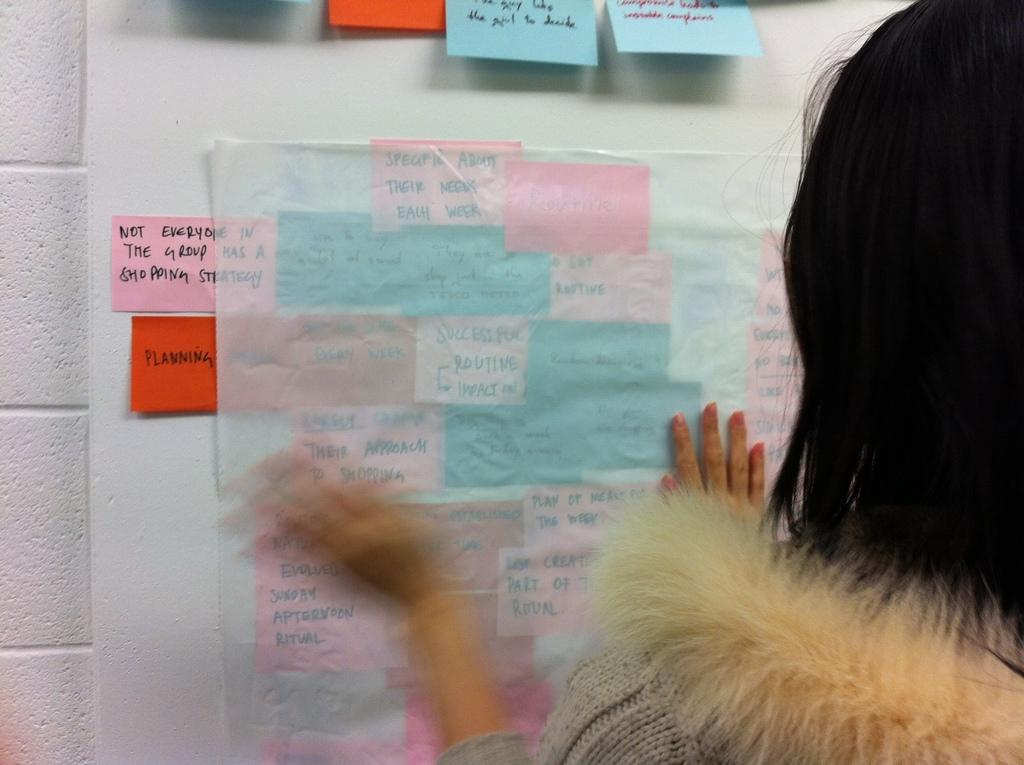Who is the main subject in the image? There is a lady in the image. What is the lady doing in the image? The lady is sticking something on the wall. What type of mist can be seen coming from the lady's elbow in the image? There is no mist present in the image, nor is there any reference to the lady's elbow. 